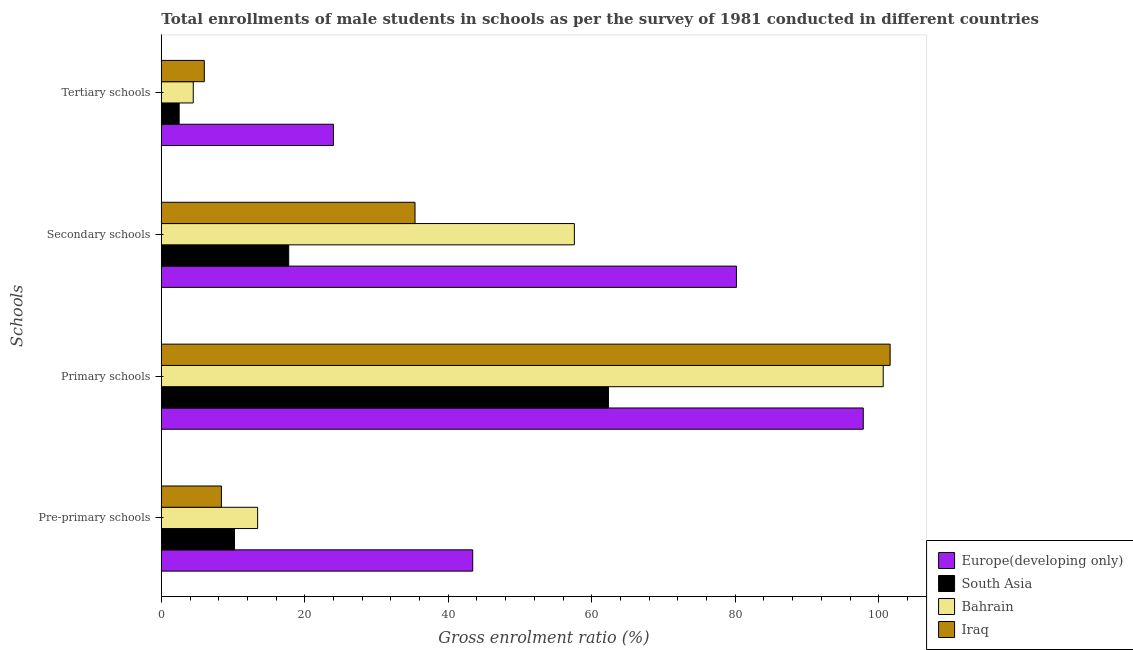How many different coloured bars are there?
Your answer should be very brief. 4. How many groups of bars are there?
Make the answer very short. 4. Are the number of bars on each tick of the Y-axis equal?
Provide a short and direct response. Yes. How many bars are there on the 3rd tick from the bottom?
Provide a short and direct response. 4. What is the label of the 3rd group of bars from the top?
Keep it short and to the point. Primary schools. What is the gross enrolment ratio(male) in secondary schools in Bahrain?
Offer a terse response. 57.58. Across all countries, what is the maximum gross enrolment ratio(male) in primary schools?
Provide a succinct answer. 101.59. Across all countries, what is the minimum gross enrolment ratio(male) in pre-primary schools?
Give a very brief answer. 8.38. In which country was the gross enrolment ratio(male) in tertiary schools maximum?
Your response must be concise. Europe(developing only). In which country was the gross enrolment ratio(male) in tertiary schools minimum?
Your answer should be very brief. South Asia. What is the total gross enrolment ratio(male) in primary schools in the graph?
Make the answer very short. 362.39. What is the difference between the gross enrolment ratio(male) in primary schools in South Asia and that in Iraq?
Your response must be concise. -39.27. What is the difference between the gross enrolment ratio(male) in pre-primary schools in Bahrain and the gross enrolment ratio(male) in tertiary schools in Europe(developing only)?
Offer a terse response. -10.56. What is the average gross enrolment ratio(male) in secondary schools per country?
Provide a short and direct response. 47.72. What is the difference between the gross enrolment ratio(male) in pre-primary schools and gross enrolment ratio(male) in secondary schools in South Asia?
Your answer should be very brief. -7.56. In how many countries, is the gross enrolment ratio(male) in pre-primary schools greater than 8 %?
Provide a succinct answer. 4. What is the ratio of the gross enrolment ratio(male) in primary schools in Bahrain to that in Iraq?
Keep it short and to the point. 0.99. Is the gross enrolment ratio(male) in tertiary schools in Iraq less than that in Europe(developing only)?
Your answer should be very brief. Yes. What is the difference between the highest and the second highest gross enrolment ratio(male) in pre-primary schools?
Ensure brevity in your answer.  29.98. What is the difference between the highest and the lowest gross enrolment ratio(male) in pre-primary schools?
Offer a very short reply. 35.03. In how many countries, is the gross enrolment ratio(male) in primary schools greater than the average gross enrolment ratio(male) in primary schools taken over all countries?
Your response must be concise. 3. Is it the case that in every country, the sum of the gross enrolment ratio(male) in tertiary schools and gross enrolment ratio(male) in pre-primary schools is greater than the sum of gross enrolment ratio(male) in secondary schools and gross enrolment ratio(male) in primary schools?
Your answer should be very brief. Yes. What does the 1st bar from the top in Pre-primary schools represents?
Provide a short and direct response. Iraq. What does the 1st bar from the bottom in Secondary schools represents?
Your answer should be very brief. Europe(developing only). Are all the bars in the graph horizontal?
Make the answer very short. Yes. Are the values on the major ticks of X-axis written in scientific E-notation?
Give a very brief answer. No. Where does the legend appear in the graph?
Offer a very short reply. Bottom right. What is the title of the graph?
Your answer should be very brief. Total enrollments of male students in schools as per the survey of 1981 conducted in different countries. Does "Chile" appear as one of the legend labels in the graph?
Your answer should be compact. No. What is the label or title of the X-axis?
Give a very brief answer. Gross enrolment ratio (%). What is the label or title of the Y-axis?
Give a very brief answer. Schools. What is the Gross enrolment ratio (%) of Europe(developing only) in Pre-primary schools?
Your answer should be compact. 43.41. What is the Gross enrolment ratio (%) in South Asia in Pre-primary schools?
Your answer should be compact. 10.2. What is the Gross enrolment ratio (%) in Bahrain in Pre-primary schools?
Make the answer very short. 13.43. What is the Gross enrolment ratio (%) of Iraq in Pre-primary schools?
Provide a short and direct response. 8.38. What is the Gross enrolment ratio (%) of Europe(developing only) in Primary schools?
Your answer should be compact. 97.85. What is the Gross enrolment ratio (%) of South Asia in Primary schools?
Offer a very short reply. 62.33. What is the Gross enrolment ratio (%) in Bahrain in Primary schools?
Give a very brief answer. 100.63. What is the Gross enrolment ratio (%) of Iraq in Primary schools?
Offer a terse response. 101.59. What is the Gross enrolment ratio (%) in Europe(developing only) in Secondary schools?
Your answer should be very brief. 80.17. What is the Gross enrolment ratio (%) of South Asia in Secondary schools?
Your answer should be compact. 17.76. What is the Gross enrolment ratio (%) of Bahrain in Secondary schools?
Your answer should be very brief. 57.58. What is the Gross enrolment ratio (%) in Iraq in Secondary schools?
Give a very brief answer. 35.36. What is the Gross enrolment ratio (%) of Europe(developing only) in Tertiary schools?
Offer a very short reply. 23.99. What is the Gross enrolment ratio (%) of South Asia in Tertiary schools?
Give a very brief answer. 2.49. What is the Gross enrolment ratio (%) in Bahrain in Tertiary schools?
Give a very brief answer. 4.45. What is the Gross enrolment ratio (%) in Iraq in Tertiary schools?
Give a very brief answer. 5.99. Across all Schools, what is the maximum Gross enrolment ratio (%) in Europe(developing only)?
Ensure brevity in your answer.  97.85. Across all Schools, what is the maximum Gross enrolment ratio (%) in South Asia?
Offer a terse response. 62.33. Across all Schools, what is the maximum Gross enrolment ratio (%) in Bahrain?
Ensure brevity in your answer.  100.63. Across all Schools, what is the maximum Gross enrolment ratio (%) in Iraq?
Offer a terse response. 101.59. Across all Schools, what is the minimum Gross enrolment ratio (%) of Europe(developing only)?
Provide a short and direct response. 23.99. Across all Schools, what is the minimum Gross enrolment ratio (%) of South Asia?
Offer a terse response. 2.49. Across all Schools, what is the minimum Gross enrolment ratio (%) in Bahrain?
Provide a succinct answer. 4.45. Across all Schools, what is the minimum Gross enrolment ratio (%) of Iraq?
Give a very brief answer. 5.99. What is the total Gross enrolment ratio (%) of Europe(developing only) in the graph?
Keep it short and to the point. 245.41. What is the total Gross enrolment ratio (%) in South Asia in the graph?
Make the answer very short. 92.77. What is the total Gross enrolment ratio (%) in Bahrain in the graph?
Offer a very short reply. 176.08. What is the total Gross enrolment ratio (%) of Iraq in the graph?
Keep it short and to the point. 151.33. What is the difference between the Gross enrolment ratio (%) of Europe(developing only) in Pre-primary schools and that in Primary schools?
Provide a succinct answer. -54.44. What is the difference between the Gross enrolment ratio (%) of South Asia in Pre-primary schools and that in Primary schools?
Give a very brief answer. -52.12. What is the difference between the Gross enrolment ratio (%) in Bahrain in Pre-primary schools and that in Primary schools?
Offer a terse response. -87.2. What is the difference between the Gross enrolment ratio (%) in Iraq in Pre-primary schools and that in Primary schools?
Offer a very short reply. -93.21. What is the difference between the Gross enrolment ratio (%) of Europe(developing only) in Pre-primary schools and that in Secondary schools?
Make the answer very short. -36.76. What is the difference between the Gross enrolment ratio (%) of South Asia in Pre-primary schools and that in Secondary schools?
Give a very brief answer. -7.56. What is the difference between the Gross enrolment ratio (%) in Bahrain in Pre-primary schools and that in Secondary schools?
Keep it short and to the point. -44.15. What is the difference between the Gross enrolment ratio (%) of Iraq in Pre-primary schools and that in Secondary schools?
Make the answer very short. -26.98. What is the difference between the Gross enrolment ratio (%) in Europe(developing only) in Pre-primary schools and that in Tertiary schools?
Make the answer very short. 19.42. What is the difference between the Gross enrolment ratio (%) of South Asia in Pre-primary schools and that in Tertiary schools?
Provide a short and direct response. 7.72. What is the difference between the Gross enrolment ratio (%) of Bahrain in Pre-primary schools and that in Tertiary schools?
Your answer should be very brief. 8.97. What is the difference between the Gross enrolment ratio (%) of Iraq in Pre-primary schools and that in Tertiary schools?
Your answer should be compact. 2.39. What is the difference between the Gross enrolment ratio (%) of Europe(developing only) in Primary schools and that in Secondary schools?
Make the answer very short. 17.68. What is the difference between the Gross enrolment ratio (%) of South Asia in Primary schools and that in Secondary schools?
Give a very brief answer. 44.57. What is the difference between the Gross enrolment ratio (%) of Bahrain in Primary schools and that in Secondary schools?
Keep it short and to the point. 43.05. What is the difference between the Gross enrolment ratio (%) of Iraq in Primary schools and that in Secondary schools?
Offer a terse response. 66.23. What is the difference between the Gross enrolment ratio (%) in Europe(developing only) in Primary schools and that in Tertiary schools?
Provide a succinct answer. 73.86. What is the difference between the Gross enrolment ratio (%) of South Asia in Primary schools and that in Tertiary schools?
Make the answer very short. 59.84. What is the difference between the Gross enrolment ratio (%) of Bahrain in Primary schools and that in Tertiary schools?
Offer a very short reply. 96.17. What is the difference between the Gross enrolment ratio (%) in Iraq in Primary schools and that in Tertiary schools?
Keep it short and to the point. 95.6. What is the difference between the Gross enrolment ratio (%) of Europe(developing only) in Secondary schools and that in Tertiary schools?
Provide a short and direct response. 56.18. What is the difference between the Gross enrolment ratio (%) of South Asia in Secondary schools and that in Tertiary schools?
Provide a succinct answer. 15.27. What is the difference between the Gross enrolment ratio (%) of Bahrain in Secondary schools and that in Tertiary schools?
Make the answer very short. 53.12. What is the difference between the Gross enrolment ratio (%) of Iraq in Secondary schools and that in Tertiary schools?
Give a very brief answer. 29.37. What is the difference between the Gross enrolment ratio (%) in Europe(developing only) in Pre-primary schools and the Gross enrolment ratio (%) in South Asia in Primary schools?
Provide a short and direct response. -18.92. What is the difference between the Gross enrolment ratio (%) of Europe(developing only) in Pre-primary schools and the Gross enrolment ratio (%) of Bahrain in Primary schools?
Provide a succinct answer. -57.22. What is the difference between the Gross enrolment ratio (%) of Europe(developing only) in Pre-primary schools and the Gross enrolment ratio (%) of Iraq in Primary schools?
Your response must be concise. -58.18. What is the difference between the Gross enrolment ratio (%) in South Asia in Pre-primary schools and the Gross enrolment ratio (%) in Bahrain in Primary schools?
Make the answer very short. -90.43. What is the difference between the Gross enrolment ratio (%) of South Asia in Pre-primary schools and the Gross enrolment ratio (%) of Iraq in Primary schools?
Provide a succinct answer. -91.39. What is the difference between the Gross enrolment ratio (%) of Bahrain in Pre-primary schools and the Gross enrolment ratio (%) of Iraq in Primary schools?
Ensure brevity in your answer.  -88.17. What is the difference between the Gross enrolment ratio (%) of Europe(developing only) in Pre-primary schools and the Gross enrolment ratio (%) of South Asia in Secondary schools?
Your response must be concise. 25.65. What is the difference between the Gross enrolment ratio (%) in Europe(developing only) in Pre-primary schools and the Gross enrolment ratio (%) in Bahrain in Secondary schools?
Your answer should be compact. -14.17. What is the difference between the Gross enrolment ratio (%) in Europe(developing only) in Pre-primary schools and the Gross enrolment ratio (%) in Iraq in Secondary schools?
Provide a succinct answer. 8.04. What is the difference between the Gross enrolment ratio (%) in South Asia in Pre-primary schools and the Gross enrolment ratio (%) in Bahrain in Secondary schools?
Ensure brevity in your answer.  -47.37. What is the difference between the Gross enrolment ratio (%) of South Asia in Pre-primary schools and the Gross enrolment ratio (%) of Iraq in Secondary schools?
Your answer should be very brief. -25.16. What is the difference between the Gross enrolment ratio (%) of Bahrain in Pre-primary schools and the Gross enrolment ratio (%) of Iraq in Secondary schools?
Your response must be concise. -21.94. What is the difference between the Gross enrolment ratio (%) in Europe(developing only) in Pre-primary schools and the Gross enrolment ratio (%) in South Asia in Tertiary schools?
Offer a terse response. 40.92. What is the difference between the Gross enrolment ratio (%) of Europe(developing only) in Pre-primary schools and the Gross enrolment ratio (%) of Bahrain in Tertiary schools?
Offer a terse response. 38.95. What is the difference between the Gross enrolment ratio (%) of Europe(developing only) in Pre-primary schools and the Gross enrolment ratio (%) of Iraq in Tertiary schools?
Keep it short and to the point. 37.41. What is the difference between the Gross enrolment ratio (%) in South Asia in Pre-primary schools and the Gross enrolment ratio (%) in Bahrain in Tertiary schools?
Provide a short and direct response. 5.75. What is the difference between the Gross enrolment ratio (%) in South Asia in Pre-primary schools and the Gross enrolment ratio (%) in Iraq in Tertiary schools?
Your answer should be very brief. 4.21. What is the difference between the Gross enrolment ratio (%) in Bahrain in Pre-primary schools and the Gross enrolment ratio (%) in Iraq in Tertiary schools?
Offer a terse response. 7.43. What is the difference between the Gross enrolment ratio (%) in Europe(developing only) in Primary schools and the Gross enrolment ratio (%) in South Asia in Secondary schools?
Give a very brief answer. 80.09. What is the difference between the Gross enrolment ratio (%) of Europe(developing only) in Primary schools and the Gross enrolment ratio (%) of Bahrain in Secondary schools?
Ensure brevity in your answer.  40.27. What is the difference between the Gross enrolment ratio (%) of Europe(developing only) in Primary schools and the Gross enrolment ratio (%) of Iraq in Secondary schools?
Make the answer very short. 62.48. What is the difference between the Gross enrolment ratio (%) in South Asia in Primary schools and the Gross enrolment ratio (%) in Bahrain in Secondary schools?
Your answer should be very brief. 4.75. What is the difference between the Gross enrolment ratio (%) of South Asia in Primary schools and the Gross enrolment ratio (%) of Iraq in Secondary schools?
Ensure brevity in your answer.  26.96. What is the difference between the Gross enrolment ratio (%) of Bahrain in Primary schools and the Gross enrolment ratio (%) of Iraq in Secondary schools?
Your answer should be compact. 65.26. What is the difference between the Gross enrolment ratio (%) in Europe(developing only) in Primary schools and the Gross enrolment ratio (%) in South Asia in Tertiary schools?
Your answer should be compact. 95.36. What is the difference between the Gross enrolment ratio (%) in Europe(developing only) in Primary schools and the Gross enrolment ratio (%) in Bahrain in Tertiary schools?
Offer a terse response. 93.39. What is the difference between the Gross enrolment ratio (%) in Europe(developing only) in Primary schools and the Gross enrolment ratio (%) in Iraq in Tertiary schools?
Provide a short and direct response. 91.86. What is the difference between the Gross enrolment ratio (%) in South Asia in Primary schools and the Gross enrolment ratio (%) in Bahrain in Tertiary schools?
Make the answer very short. 57.87. What is the difference between the Gross enrolment ratio (%) of South Asia in Primary schools and the Gross enrolment ratio (%) of Iraq in Tertiary schools?
Offer a terse response. 56.33. What is the difference between the Gross enrolment ratio (%) of Bahrain in Primary schools and the Gross enrolment ratio (%) of Iraq in Tertiary schools?
Ensure brevity in your answer.  94.64. What is the difference between the Gross enrolment ratio (%) in Europe(developing only) in Secondary schools and the Gross enrolment ratio (%) in South Asia in Tertiary schools?
Your answer should be very brief. 77.68. What is the difference between the Gross enrolment ratio (%) of Europe(developing only) in Secondary schools and the Gross enrolment ratio (%) of Bahrain in Tertiary schools?
Keep it short and to the point. 75.71. What is the difference between the Gross enrolment ratio (%) of Europe(developing only) in Secondary schools and the Gross enrolment ratio (%) of Iraq in Tertiary schools?
Provide a succinct answer. 74.18. What is the difference between the Gross enrolment ratio (%) in South Asia in Secondary schools and the Gross enrolment ratio (%) in Bahrain in Tertiary schools?
Your answer should be compact. 13.3. What is the difference between the Gross enrolment ratio (%) of South Asia in Secondary schools and the Gross enrolment ratio (%) of Iraq in Tertiary schools?
Your response must be concise. 11.77. What is the difference between the Gross enrolment ratio (%) in Bahrain in Secondary schools and the Gross enrolment ratio (%) in Iraq in Tertiary schools?
Offer a very short reply. 51.58. What is the average Gross enrolment ratio (%) of Europe(developing only) per Schools?
Provide a succinct answer. 61.35. What is the average Gross enrolment ratio (%) in South Asia per Schools?
Give a very brief answer. 23.19. What is the average Gross enrolment ratio (%) in Bahrain per Schools?
Ensure brevity in your answer.  44.02. What is the average Gross enrolment ratio (%) in Iraq per Schools?
Ensure brevity in your answer.  37.83. What is the difference between the Gross enrolment ratio (%) of Europe(developing only) and Gross enrolment ratio (%) of South Asia in Pre-primary schools?
Offer a terse response. 33.21. What is the difference between the Gross enrolment ratio (%) in Europe(developing only) and Gross enrolment ratio (%) in Bahrain in Pre-primary schools?
Ensure brevity in your answer.  29.98. What is the difference between the Gross enrolment ratio (%) of Europe(developing only) and Gross enrolment ratio (%) of Iraq in Pre-primary schools?
Your answer should be very brief. 35.03. What is the difference between the Gross enrolment ratio (%) in South Asia and Gross enrolment ratio (%) in Bahrain in Pre-primary schools?
Give a very brief answer. -3.22. What is the difference between the Gross enrolment ratio (%) in South Asia and Gross enrolment ratio (%) in Iraq in Pre-primary schools?
Make the answer very short. 1.82. What is the difference between the Gross enrolment ratio (%) of Bahrain and Gross enrolment ratio (%) of Iraq in Pre-primary schools?
Provide a succinct answer. 5.05. What is the difference between the Gross enrolment ratio (%) of Europe(developing only) and Gross enrolment ratio (%) of South Asia in Primary schools?
Provide a succinct answer. 35.52. What is the difference between the Gross enrolment ratio (%) in Europe(developing only) and Gross enrolment ratio (%) in Bahrain in Primary schools?
Keep it short and to the point. -2.78. What is the difference between the Gross enrolment ratio (%) of Europe(developing only) and Gross enrolment ratio (%) of Iraq in Primary schools?
Provide a succinct answer. -3.74. What is the difference between the Gross enrolment ratio (%) of South Asia and Gross enrolment ratio (%) of Bahrain in Primary schools?
Your response must be concise. -38.3. What is the difference between the Gross enrolment ratio (%) of South Asia and Gross enrolment ratio (%) of Iraq in Primary schools?
Your answer should be very brief. -39.27. What is the difference between the Gross enrolment ratio (%) of Bahrain and Gross enrolment ratio (%) of Iraq in Primary schools?
Offer a terse response. -0.96. What is the difference between the Gross enrolment ratio (%) in Europe(developing only) and Gross enrolment ratio (%) in South Asia in Secondary schools?
Offer a very short reply. 62.41. What is the difference between the Gross enrolment ratio (%) in Europe(developing only) and Gross enrolment ratio (%) in Bahrain in Secondary schools?
Your response must be concise. 22.59. What is the difference between the Gross enrolment ratio (%) of Europe(developing only) and Gross enrolment ratio (%) of Iraq in Secondary schools?
Offer a very short reply. 44.8. What is the difference between the Gross enrolment ratio (%) in South Asia and Gross enrolment ratio (%) in Bahrain in Secondary schools?
Ensure brevity in your answer.  -39.82. What is the difference between the Gross enrolment ratio (%) in South Asia and Gross enrolment ratio (%) in Iraq in Secondary schools?
Make the answer very short. -17.61. What is the difference between the Gross enrolment ratio (%) of Bahrain and Gross enrolment ratio (%) of Iraq in Secondary schools?
Your answer should be compact. 22.21. What is the difference between the Gross enrolment ratio (%) of Europe(developing only) and Gross enrolment ratio (%) of South Asia in Tertiary schools?
Your answer should be very brief. 21.5. What is the difference between the Gross enrolment ratio (%) of Europe(developing only) and Gross enrolment ratio (%) of Bahrain in Tertiary schools?
Give a very brief answer. 19.54. What is the difference between the Gross enrolment ratio (%) in Europe(developing only) and Gross enrolment ratio (%) in Iraq in Tertiary schools?
Your response must be concise. 18. What is the difference between the Gross enrolment ratio (%) of South Asia and Gross enrolment ratio (%) of Bahrain in Tertiary schools?
Make the answer very short. -1.97. What is the difference between the Gross enrolment ratio (%) in South Asia and Gross enrolment ratio (%) in Iraq in Tertiary schools?
Give a very brief answer. -3.51. What is the difference between the Gross enrolment ratio (%) of Bahrain and Gross enrolment ratio (%) of Iraq in Tertiary schools?
Offer a very short reply. -1.54. What is the ratio of the Gross enrolment ratio (%) of Europe(developing only) in Pre-primary schools to that in Primary schools?
Your response must be concise. 0.44. What is the ratio of the Gross enrolment ratio (%) of South Asia in Pre-primary schools to that in Primary schools?
Make the answer very short. 0.16. What is the ratio of the Gross enrolment ratio (%) of Bahrain in Pre-primary schools to that in Primary schools?
Make the answer very short. 0.13. What is the ratio of the Gross enrolment ratio (%) in Iraq in Pre-primary schools to that in Primary schools?
Offer a terse response. 0.08. What is the ratio of the Gross enrolment ratio (%) of Europe(developing only) in Pre-primary schools to that in Secondary schools?
Your answer should be compact. 0.54. What is the ratio of the Gross enrolment ratio (%) of South Asia in Pre-primary schools to that in Secondary schools?
Provide a succinct answer. 0.57. What is the ratio of the Gross enrolment ratio (%) of Bahrain in Pre-primary schools to that in Secondary schools?
Your response must be concise. 0.23. What is the ratio of the Gross enrolment ratio (%) in Iraq in Pre-primary schools to that in Secondary schools?
Your response must be concise. 0.24. What is the ratio of the Gross enrolment ratio (%) in Europe(developing only) in Pre-primary schools to that in Tertiary schools?
Ensure brevity in your answer.  1.81. What is the ratio of the Gross enrolment ratio (%) of South Asia in Pre-primary schools to that in Tertiary schools?
Provide a succinct answer. 4.1. What is the ratio of the Gross enrolment ratio (%) of Bahrain in Pre-primary schools to that in Tertiary schools?
Your answer should be very brief. 3.01. What is the ratio of the Gross enrolment ratio (%) of Iraq in Pre-primary schools to that in Tertiary schools?
Provide a short and direct response. 1.4. What is the ratio of the Gross enrolment ratio (%) in Europe(developing only) in Primary schools to that in Secondary schools?
Keep it short and to the point. 1.22. What is the ratio of the Gross enrolment ratio (%) of South Asia in Primary schools to that in Secondary schools?
Your answer should be compact. 3.51. What is the ratio of the Gross enrolment ratio (%) of Bahrain in Primary schools to that in Secondary schools?
Your answer should be compact. 1.75. What is the ratio of the Gross enrolment ratio (%) of Iraq in Primary schools to that in Secondary schools?
Your response must be concise. 2.87. What is the ratio of the Gross enrolment ratio (%) of Europe(developing only) in Primary schools to that in Tertiary schools?
Keep it short and to the point. 4.08. What is the ratio of the Gross enrolment ratio (%) in South Asia in Primary schools to that in Tertiary schools?
Your response must be concise. 25.07. What is the ratio of the Gross enrolment ratio (%) of Bahrain in Primary schools to that in Tertiary schools?
Your answer should be compact. 22.59. What is the ratio of the Gross enrolment ratio (%) in Iraq in Primary schools to that in Tertiary schools?
Make the answer very short. 16.95. What is the ratio of the Gross enrolment ratio (%) in Europe(developing only) in Secondary schools to that in Tertiary schools?
Make the answer very short. 3.34. What is the ratio of the Gross enrolment ratio (%) of South Asia in Secondary schools to that in Tertiary schools?
Offer a terse response. 7.14. What is the ratio of the Gross enrolment ratio (%) in Bahrain in Secondary schools to that in Tertiary schools?
Make the answer very short. 12.93. What is the ratio of the Gross enrolment ratio (%) of Iraq in Secondary schools to that in Tertiary schools?
Keep it short and to the point. 5.9. What is the difference between the highest and the second highest Gross enrolment ratio (%) of Europe(developing only)?
Provide a succinct answer. 17.68. What is the difference between the highest and the second highest Gross enrolment ratio (%) in South Asia?
Your response must be concise. 44.57. What is the difference between the highest and the second highest Gross enrolment ratio (%) of Bahrain?
Your answer should be compact. 43.05. What is the difference between the highest and the second highest Gross enrolment ratio (%) in Iraq?
Give a very brief answer. 66.23. What is the difference between the highest and the lowest Gross enrolment ratio (%) of Europe(developing only)?
Give a very brief answer. 73.86. What is the difference between the highest and the lowest Gross enrolment ratio (%) in South Asia?
Ensure brevity in your answer.  59.84. What is the difference between the highest and the lowest Gross enrolment ratio (%) of Bahrain?
Your answer should be very brief. 96.17. What is the difference between the highest and the lowest Gross enrolment ratio (%) of Iraq?
Your answer should be compact. 95.6. 